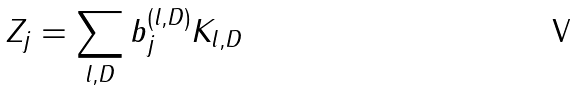<formula> <loc_0><loc_0><loc_500><loc_500>Z _ { j } = \sum _ { l , D } b ^ { ( l , D ) } _ { j } K _ { l , D }</formula> 